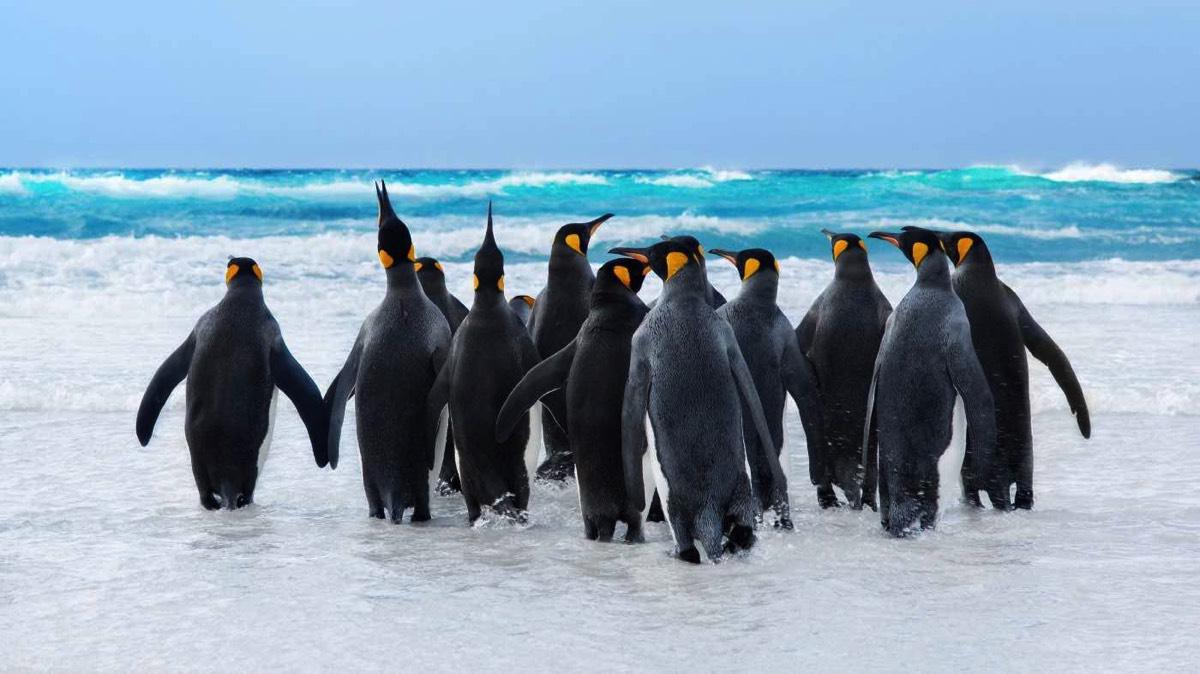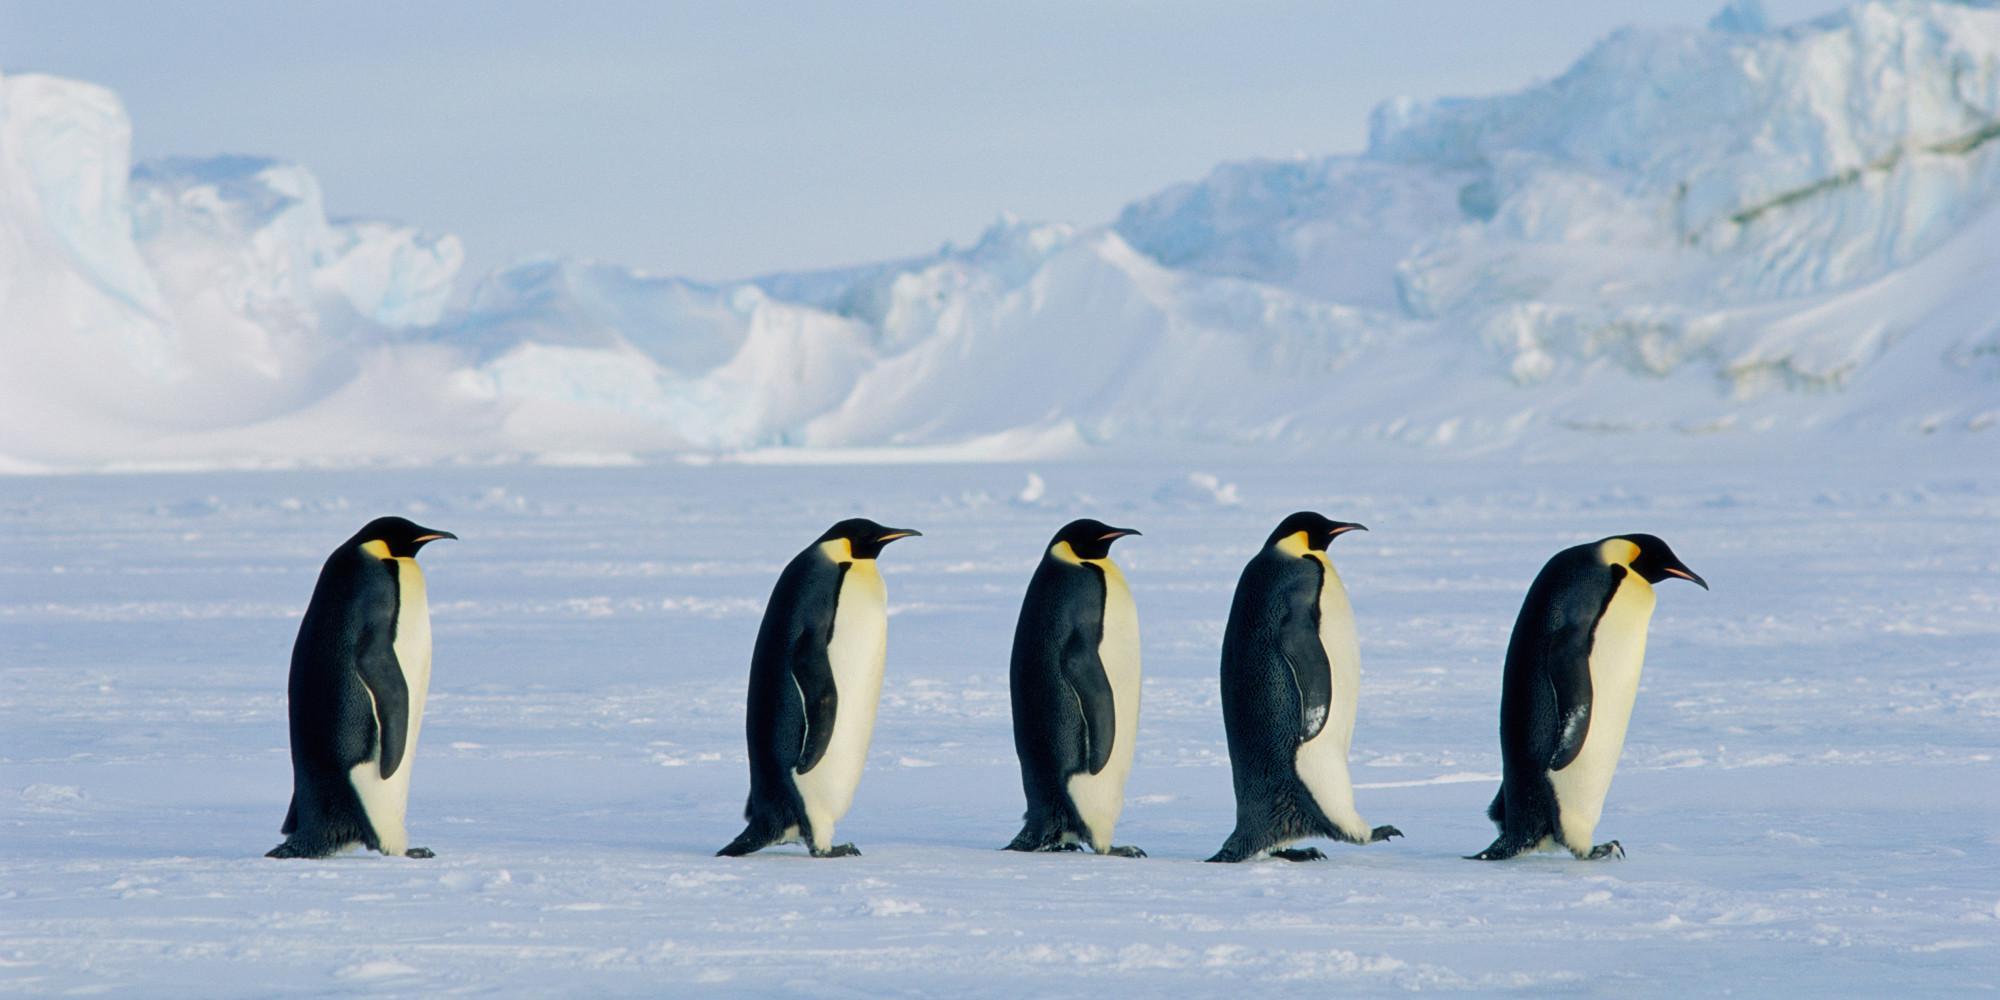The first image is the image on the left, the second image is the image on the right. Analyze the images presented: Is the assertion "multiple peguins white bellies are facing the camera" valid? Answer yes or no. No. The first image is the image on the left, the second image is the image on the right. Analyze the images presented: Is the assertion "An image shows a horizontal row of upright penguins, all facing right." valid? Answer yes or no. Yes. 